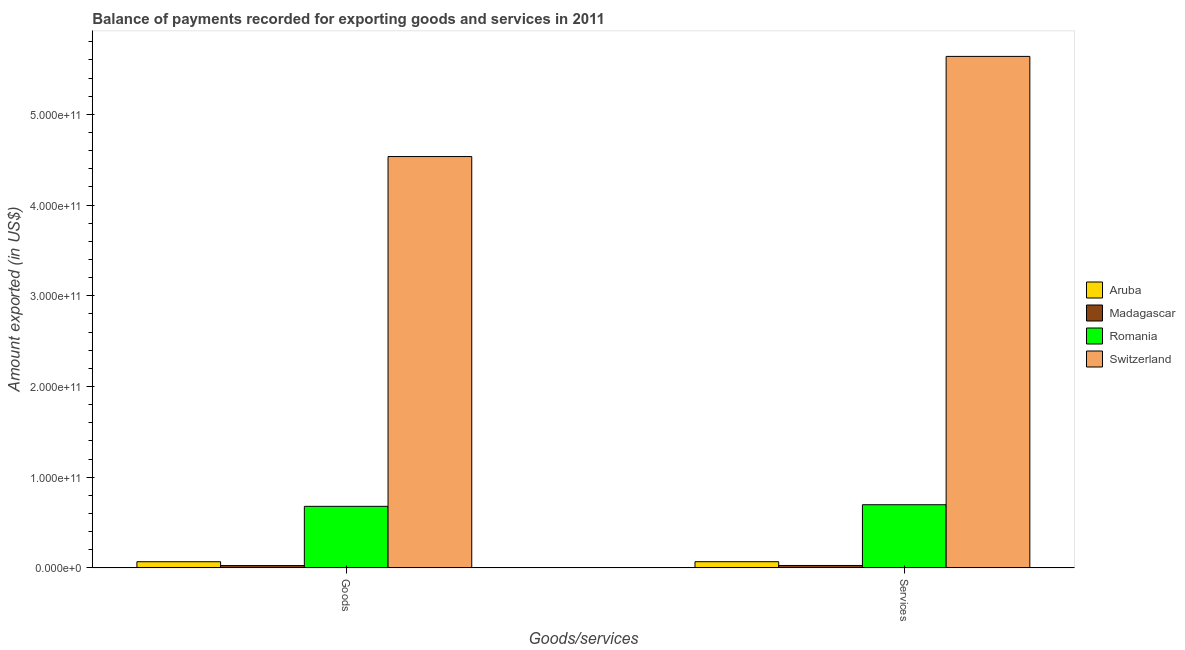How many different coloured bars are there?
Your response must be concise. 4. Are the number of bars per tick equal to the number of legend labels?
Keep it short and to the point. Yes. What is the label of the 1st group of bars from the left?
Give a very brief answer. Goods. What is the amount of services exported in Romania?
Make the answer very short. 6.97e+1. Across all countries, what is the maximum amount of goods exported?
Ensure brevity in your answer.  4.54e+11. Across all countries, what is the minimum amount of services exported?
Offer a very short reply. 2.73e+09. In which country was the amount of services exported maximum?
Keep it short and to the point. Switzerland. In which country was the amount of services exported minimum?
Your answer should be compact. Madagascar. What is the total amount of goods exported in the graph?
Provide a short and direct response. 5.31e+11. What is the difference between the amount of goods exported in Romania and that in Aruba?
Keep it short and to the point. 6.11e+1. What is the difference between the amount of services exported in Switzerland and the amount of goods exported in Aruba?
Provide a succinct answer. 5.57e+11. What is the average amount of goods exported per country?
Your response must be concise. 1.33e+11. What is the difference between the amount of services exported and amount of goods exported in Aruba?
Your answer should be compact. 4.04e+07. What is the ratio of the amount of goods exported in Madagascar to that in Switzerland?
Provide a short and direct response. 0.01. In how many countries, is the amount of goods exported greater than the average amount of goods exported taken over all countries?
Make the answer very short. 1. What does the 3rd bar from the left in Goods represents?
Make the answer very short. Romania. What does the 1st bar from the right in Services represents?
Keep it short and to the point. Switzerland. What is the difference between two consecutive major ticks on the Y-axis?
Your answer should be very brief. 1.00e+11. Does the graph contain any zero values?
Offer a terse response. No. Where does the legend appear in the graph?
Your response must be concise. Center right. How many legend labels are there?
Your answer should be compact. 4. How are the legend labels stacked?
Keep it short and to the point. Vertical. What is the title of the graph?
Your response must be concise. Balance of payments recorded for exporting goods and services in 2011. What is the label or title of the X-axis?
Provide a succinct answer. Goods/services. What is the label or title of the Y-axis?
Your answer should be very brief. Amount exported (in US$). What is the Amount exported (in US$) in Aruba in Goods?
Keep it short and to the point. 6.86e+09. What is the Amount exported (in US$) in Madagascar in Goods?
Provide a short and direct response. 2.65e+09. What is the Amount exported (in US$) of Romania in Goods?
Make the answer very short. 6.79e+1. What is the Amount exported (in US$) in Switzerland in Goods?
Your answer should be compact. 4.54e+11. What is the Amount exported (in US$) of Aruba in Services?
Keep it short and to the point. 6.90e+09. What is the Amount exported (in US$) in Madagascar in Services?
Ensure brevity in your answer.  2.73e+09. What is the Amount exported (in US$) in Romania in Services?
Your response must be concise. 6.97e+1. What is the Amount exported (in US$) in Switzerland in Services?
Offer a very short reply. 5.64e+11. Across all Goods/services, what is the maximum Amount exported (in US$) of Aruba?
Ensure brevity in your answer.  6.90e+09. Across all Goods/services, what is the maximum Amount exported (in US$) of Madagascar?
Your response must be concise. 2.73e+09. Across all Goods/services, what is the maximum Amount exported (in US$) of Romania?
Provide a succinct answer. 6.97e+1. Across all Goods/services, what is the maximum Amount exported (in US$) of Switzerland?
Ensure brevity in your answer.  5.64e+11. Across all Goods/services, what is the minimum Amount exported (in US$) in Aruba?
Give a very brief answer. 6.86e+09. Across all Goods/services, what is the minimum Amount exported (in US$) of Madagascar?
Provide a short and direct response. 2.65e+09. Across all Goods/services, what is the minimum Amount exported (in US$) of Romania?
Offer a very short reply. 6.79e+1. Across all Goods/services, what is the minimum Amount exported (in US$) of Switzerland?
Make the answer very short. 4.54e+11. What is the total Amount exported (in US$) of Aruba in the graph?
Provide a short and direct response. 1.38e+1. What is the total Amount exported (in US$) in Madagascar in the graph?
Offer a terse response. 5.38e+09. What is the total Amount exported (in US$) in Romania in the graph?
Provide a succinct answer. 1.38e+11. What is the total Amount exported (in US$) in Switzerland in the graph?
Your answer should be very brief. 1.02e+12. What is the difference between the Amount exported (in US$) of Aruba in Goods and that in Services?
Give a very brief answer. -4.04e+07. What is the difference between the Amount exported (in US$) of Madagascar in Goods and that in Services?
Give a very brief answer. -8.52e+07. What is the difference between the Amount exported (in US$) in Romania in Goods and that in Services?
Give a very brief answer. -1.77e+09. What is the difference between the Amount exported (in US$) in Switzerland in Goods and that in Services?
Provide a short and direct response. -1.10e+11. What is the difference between the Amount exported (in US$) of Aruba in Goods and the Amount exported (in US$) of Madagascar in Services?
Your response must be concise. 4.13e+09. What is the difference between the Amount exported (in US$) of Aruba in Goods and the Amount exported (in US$) of Romania in Services?
Your response must be concise. -6.28e+1. What is the difference between the Amount exported (in US$) of Aruba in Goods and the Amount exported (in US$) of Switzerland in Services?
Keep it short and to the point. -5.57e+11. What is the difference between the Amount exported (in US$) in Madagascar in Goods and the Amount exported (in US$) in Romania in Services?
Your answer should be very brief. -6.70e+1. What is the difference between the Amount exported (in US$) in Madagascar in Goods and the Amount exported (in US$) in Switzerland in Services?
Keep it short and to the point. -5.61e+11. What is the difference between the Amount exported (in US$) in Romania in Goods and the Amount exported (in US$) in Switzerland in Services?
Ensure brevity in your answer.  -4.96e+11. What is the average Amount exported (in US$) in Aruba per Goods/services?
Keep it short and to the point. 6.88e+09. What is the average Amount exported (in US$) of Madagascar per Goods/services?
Your response must be concise. 2.69e+09. What is the average Amount exported (in US$) of Romania per Goods/services?
Your response must be concise. 6.88e+1. What is the average Amount exported (in US$) of Switzerland per Goods/services?
Your answer should be very brief. 5.09e+11. What is the difference between the Amount exported (in US$) of Aruba and Amount exported (in US$) of Madagascar in Goods?
Your answer should be very brief. 4.21e+09. What is the difference between the Amount exported (in US$) of Aruba and Amount exported (in US$) of Romania in Goods?
Give a very brief answer. -6.11e+1. What is the difference between the Amount exported (in US$) of Aruba and Amount exported (in US$) of Switzerland in Goods?
Keep it short and to the point. -4.47e+11. What is the difference between the Amount exported (in US$) in Madagascar and Amount exported (in US$) in Romania in Goods?
Your response must be concise. -6.53e+1. What is the difference between the Amount exported (in US$) of Madagascar and Amount exported (in US$) of Switzerland in Goods?
Your answer should be very brief. -4.51e+11. What is the difference between the Amount exported (in US$) of Romania and Amount exported (in US$) of Switzerland in Goods?
Offer a terse response. -3.86e+11. What is the difference between the Amount exported (in US$) of Aruba and Amount exported (in US$) of Madagascar in Services?
Keep it short and to the point. 4.17e+09. What is the difference between the Amount exported (in US$) of Aruba and Amount exported (in US$) of Romania in Services?
Your response must be concise. -6.28e+1. What is the difference between the Amount exported (in US$) of Aruba and Amount exported (in US$) of Switzerland in Services?
Provide a succinct answer. -5.57e+11. What is the difference between the Amount exported (in US$) of Madagascar and Amount exported (in US$) of Romania in Services?
Give a very brief answer. -6.70e+1. What is the difference between the Amount exported (in US$) in Madagascar and Amount exported (in US$) in Switzerland in Services?
Ensure brevity in your answer.  -5.61e+11. What is the difference between the Amount exported (in US$) in Romania and Amount exported (in US$) in Switzerland in Services?
Offer a very short reply. -4.94e+11. What is the ratio of the Amount exported (in US$) of Madagascar in Goods to that in Services?
Offer a terse response. 0.97. What is the ratio of the Amount exported (in US$) in Romania in Goods to that in Services?
Your answer should be compact. 0.97. What is the ratio of the Amount exported (in US$) of Switzerland in Goods to that in Services?
Offer a very short reply. 0.8. What is the difference between the highest and the second highest Amount exported (in US$) of Aruba?
Give a very brief answer. 4.04e+07. What is the difference between the highest and the second highest Amount exported (in US$) of Madagascar?
Provide a succinct answer. 8.52e+07. What is the difference between the highest and the second highest Amount exported (in US$) of Romania?
Offer a terse response. 1.77e+09. What is the difference between the highest and the second highest Amount exported (in US$) in Switzerland?
Provide a short and direct response. 1.10e+11. What is the difference between the highest and the lowest Amount exported (in US$) in Aruba?
Your response must be concise. 4.04e+07. What is the difference between the highest and the lowest Amount exported (in US$) of Madagascar?
Give a very brief answer. 8.52e+07. What is the difference between the highest and the lowest Amount exported (in US$) in Romania?
Provide a succinct answer. 1.77e+09. What is the difference between the highest and the lowest Amount exported (in US$) of Switzerland?
Ensure brevity in your answer.  1.10e+11. 